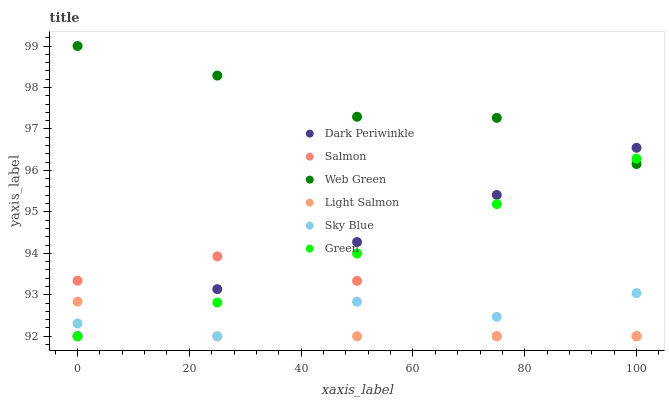Does Light Salmon have the minimum area under the curve?
Answer yes or no. Yes. Does Web Green have the maximum area under the curve?
Answer yes or no. Yes. Does Salmon have the minimum area under the curve?
Answer yes or no. No. Does Salmon have the maximum area under the curve?
Answer yes or no. No. Is Dark Periwinkle the smoothest?
Answer yes or no. Yes. Is Sky Blue the roughest?
Answer yes or no. Yes. Is Salmon the smoothest?
Answer yes or no. No. Is Salmon the roughest?
Answer yes or no. No. Does Light Salmon have the lowest value?
Answer yes or no. Yes. Does Web Green have the lowest value?
Answer yes or no. No. Does Web Green have the highest value?
Answer yes or no. Yes. Does Salmon have the highest value?
Answer yes or no. No. Is Light Salmon less than Web Green?
Answer yes or no. Yes. Is Web Green greater than Sky Blue?
Answer yes or no. Yes. Does Web Green intersect Green?
Answer yes or no. Yes. Is Web Green less than Green?
Answer yes or no. No. Is Web Green greater than Green?
Answer yes or no. No. Does Light Salmon intersect Web Green?
Answer yes or no. No. 